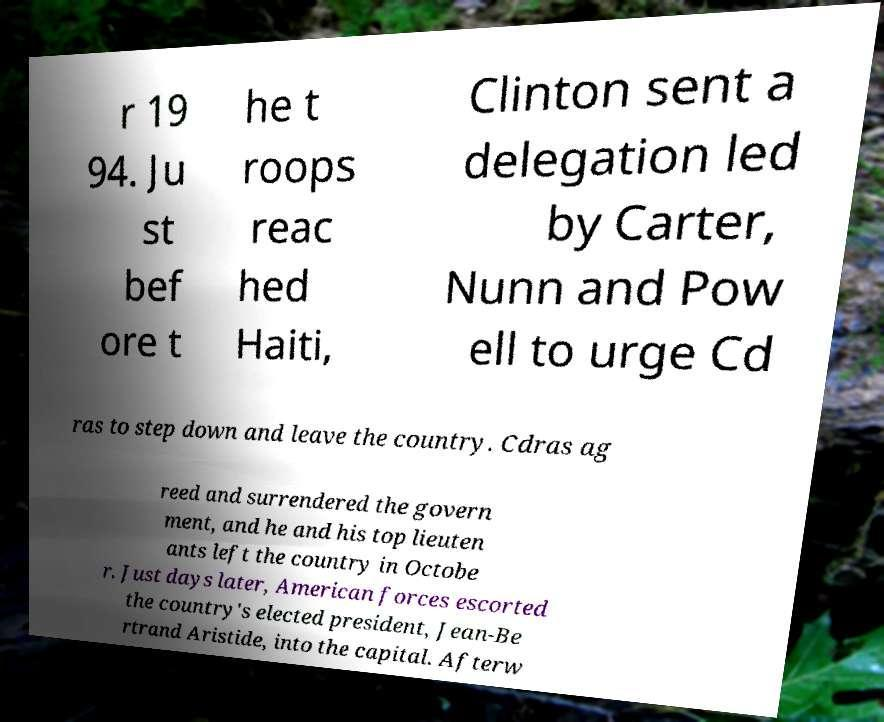Can you accurately transcribe the text from the provided image for me? r 19 94. Ju st bef ore t he t roops reac hed Haiti, Clinton sent a delegation led by Carter, Nunn and Pow ell to urge Cd ras to step down and leave the country. Cdras ag reed and surrendered the govern ment, and he and his top lieuten ants left the country in Octobe r. Just days later, American forces escorted the country's elected president, Jean-Be rtrand Aristide, into the capital. Afterw 